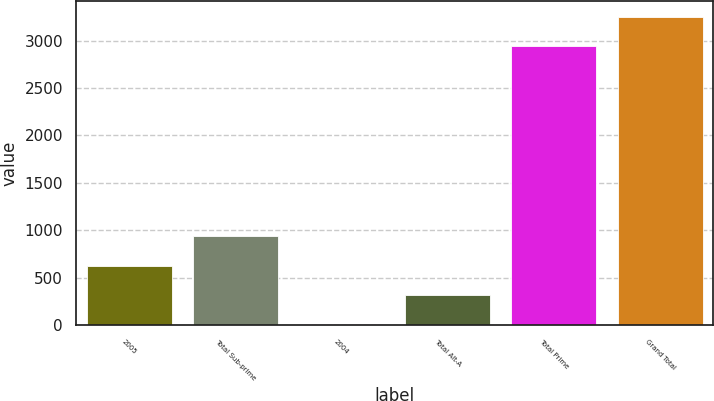<chart> <loc_0><loc_0><loc_500><loc_500><bar_chart><fcel>2005<fcel>Total Sub-prime<fcel>2004<fcel>Total Alt-A<fcel>Total Prime<fcel>Grand Total<nl><fcel>627.6<fcel>935.4<fcel>12<fcel>319.8<fcel>2944<fcel>3251.8<nl></chart> 